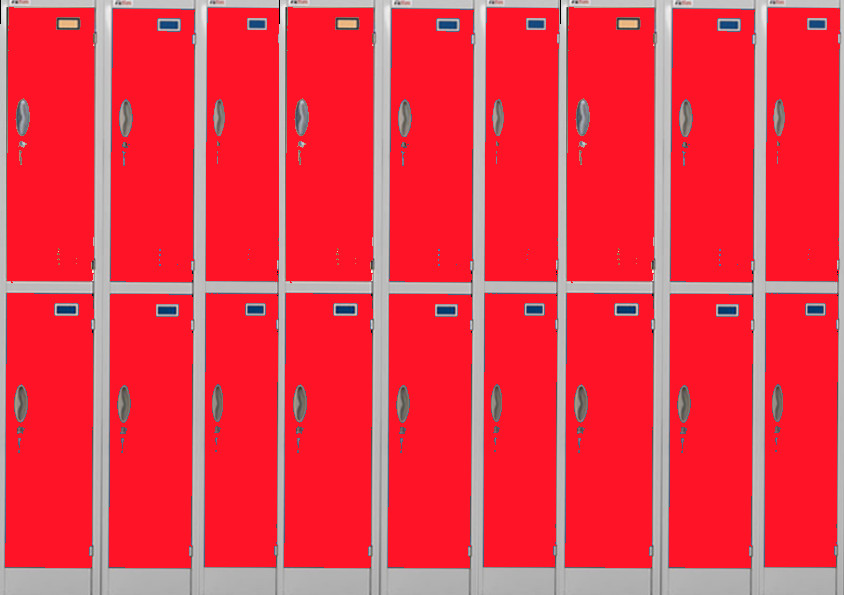What kind of environment do you think these lockers are in? The red lockers with blue stickers, their uniform design, and the clean, orderly arrangement suggest these lockers are in an environment that prioritizes organization and efficiency. This could be a school, gym, office building, or any other setting where secure storage is needed. The bright red color might be chosen for its visibility and the uniform design indicates a modern, well-maintained facility. Do you have any guesses as to who might be using these lockers? Given that the lockers are well-maintained and have labels for organization, they might be used by students at a school, employees at a company, or members at a gym. The environment seems structured and the lockers look functional and orderly, which suits a wide range of users who need a secure place to store their belongings while participating in activities or during their daily routines. Can you describe a typical day in the life of someone using these lockers? Sure! Let’s imagine a high school student using these lockers. They arrive at school in the morning and head straight to their locker to store their bag and books. They would use the locker a few times throughout the day between classes to exchange books and gather their materials. At lunch, they might store their sports gear in the locker for their after-school activities. The blue label on the locker could help them quickly identify it among the many red lockers, making their school day more efficient. At the end of the day, they collect everything they need and head home, ready to repeat the pattern the next day. 